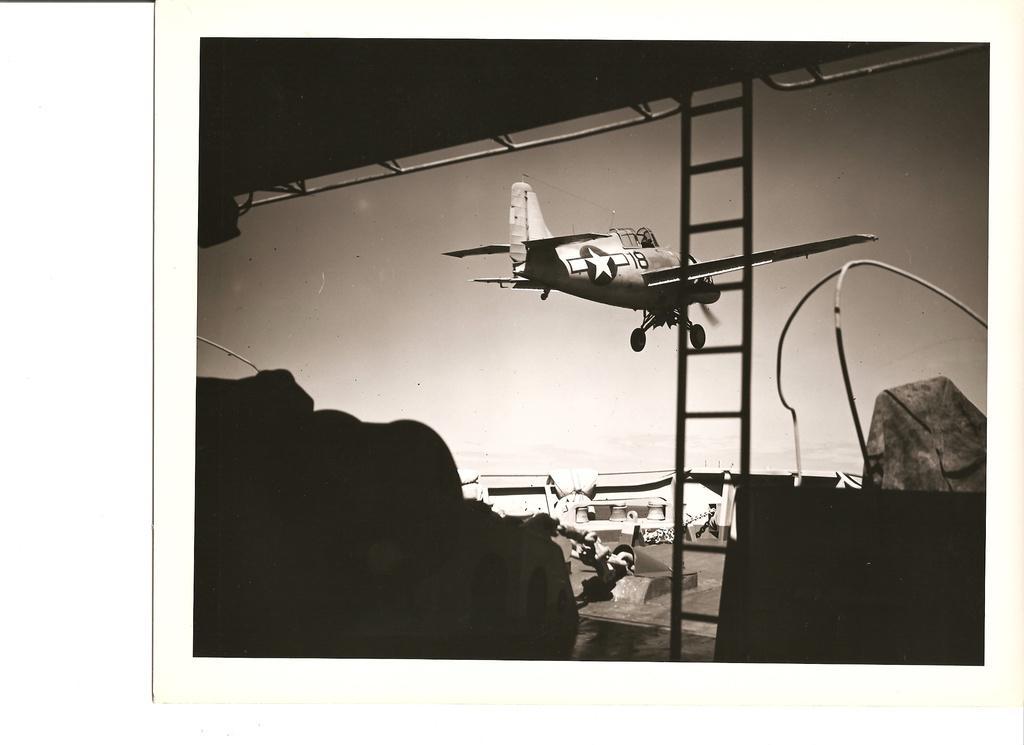In one or two sentences, can you explain what this image depicts? This is a black and white image. I can see an aircraft flying. This looks like a ladder. In the background, I think this is a building. These are the objects. 